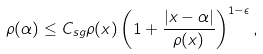Convert formula to latex. <formula><loc_0><loc_0><loc_500><loc_500>\rho ( \alpha ) \leq C _ { s g } \rho ( x ) \left ( 1 + \frac { | x - \alpha | } { \rho ( x ) } \right ) ^ { 1 - \epsilon } ,</formula> 